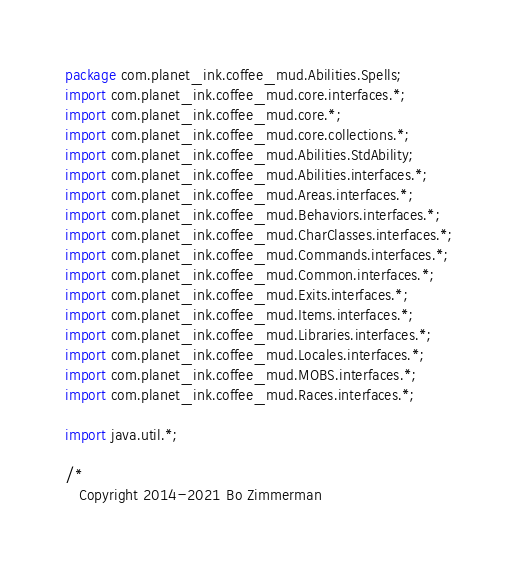Convert code to text. <code><loc_0><loc_0><loc_500><loc_500><_Java_>package com.planet_ink.coffee_mud.Abilities.Spells;
import com.planet_ink.coffee_mud.core.interfaces.*;
import com.planet_ink.coffee_mud.core.*;
import com.planet_ink.coffee_mud.core.collections.*;
import com.planet_ink.coffee_mud.Abilities.StdAbility;
import com.planet_ink.coffee_mud.Abilities.interfaces.*;
import com.planet_ink.coffee_mud.Areas.interfaces.*;
import com.planet_ink.coffee_mud.Behaviors.interfaces.*;
import com.planet_ink.coffee_mud.CharClasses.interfaces.*;
import com.planet_ink.coffee_mud.Commands.interfaces.*;
import com.planet_ink.coffee_mud.Common.interfaces.*;
import com.planet_ink.coffee_mud.Exits.interfaces.*;
import com.planet_ink.coffee_mud.Items.interfaces.*;
import com.planet_ink.coffee_mud.Libraries.interfaces.*;
import com.planet_ink.coffee_mud.Locales.interfaces.*;
import com.planet_ink.coffee_mud.MOBS.interfaces.*;
import com.planet_ink.coffee_mud.Races.interfaces.*;

import java.util.*;

/*
   Copyright 2014-2021 Bo Zimmerman
</code> 